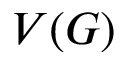<formula> <loc_0><loc_0><loc_500><loc_500>V ( G )</formula> 